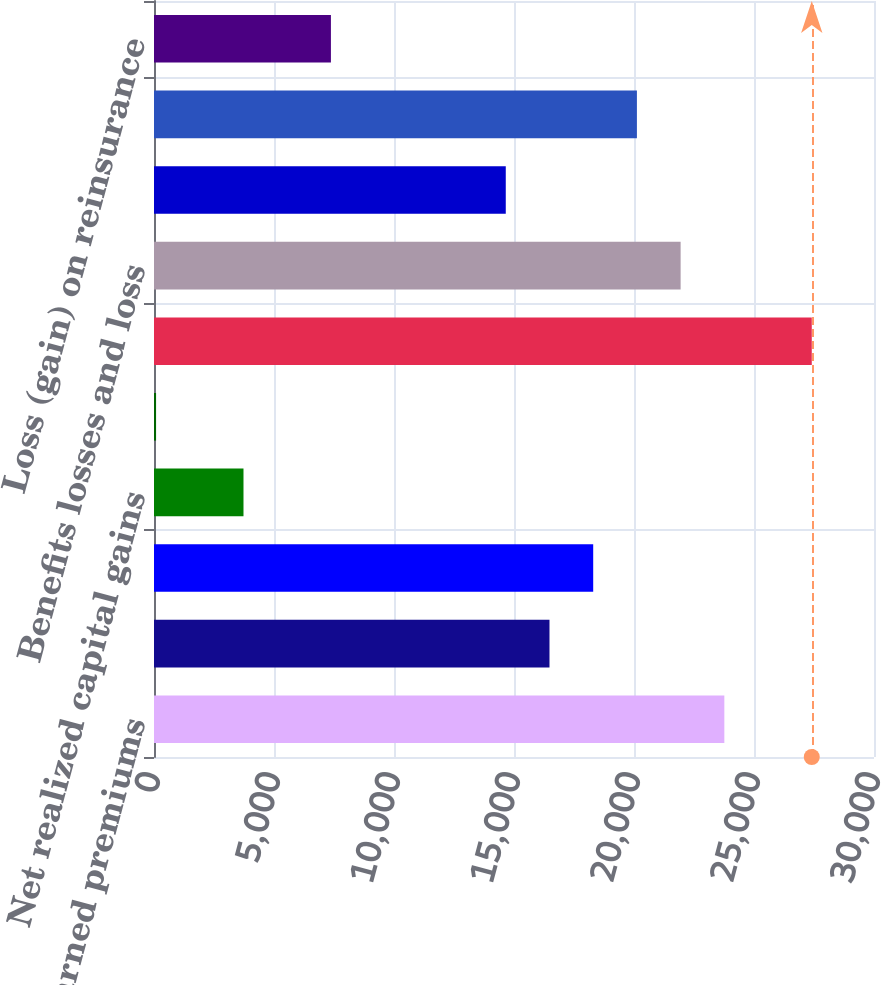Convert chart. <chart><loc_0><loc_0><loc_500><loc_500><bar_chart><fcel>Earned premiums<fcel>Fee income<fcel>Net investment income<fcel>Net realized capital gains<fcel>Other revenues<fcel>Total revenues<fcel>Benefits losses and loss<fcel>Amortization of deferred<fcel>Insurance operating costs and<fcel>Loss (gain) on reinsurance<nl><fcel>23764.2<fcel>16478.6<fcel>18300<fcel>3728.8<fcel>86<fcel>27407<fcel>21942.8<fcel>14657.2<fcel>20121.4<fcel>7371.6<nl></chart> 